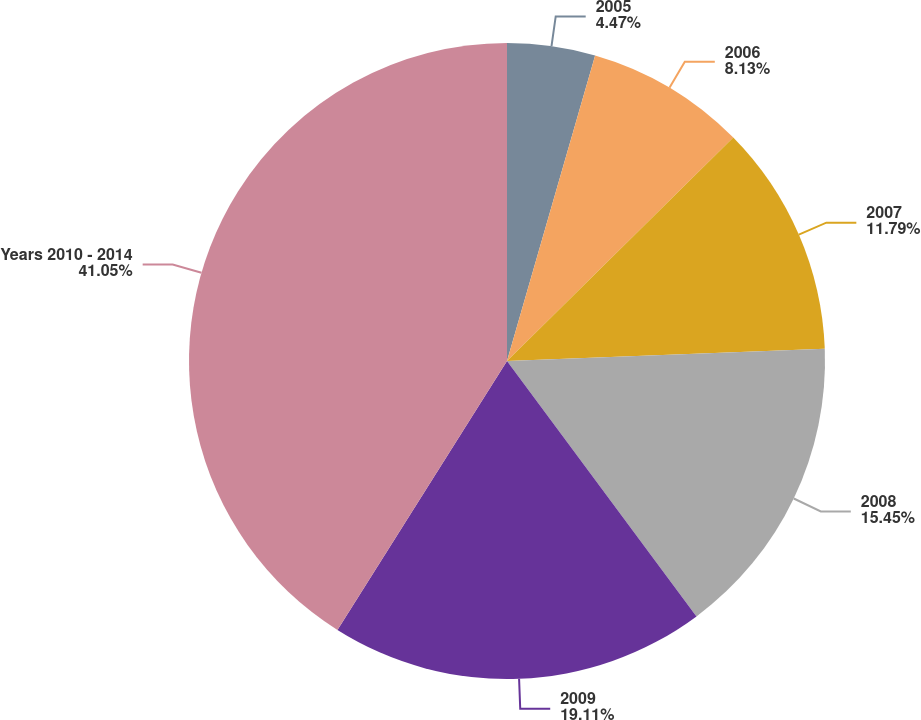<chart> <loc_0><loc_0><loc_500><loc_500><pie_chart><fcel>2005<fcel>2006<fcel>2007<fcel>2008<fcel>2009<fcel>Years 2010 - 2014<nl><fcel>4.47%<fcel>8.13%<fcel>11.79%<fcel>15.45%<fcel>19.11%<fcel>41.05%<nl></chart> 